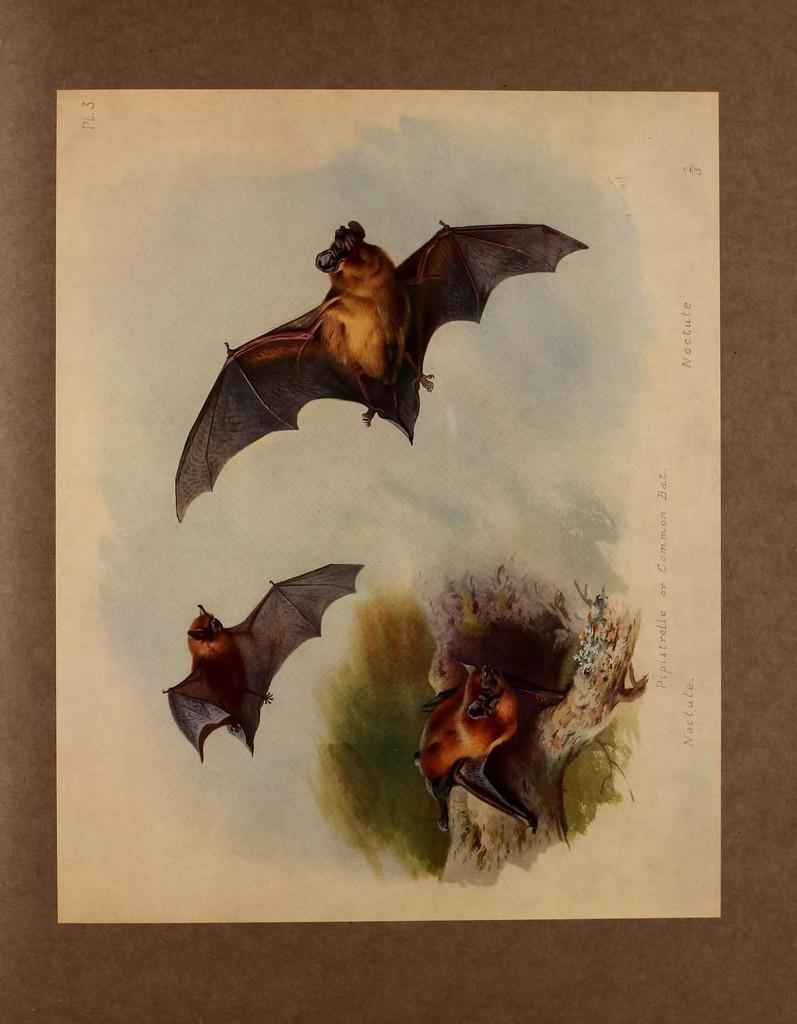What type of artwork is depicted in the image? The image is a painting. What animals are present in the painting? There are bats in the painting. What other object can be seen in the painting? There is a tree trunk in the painting. What color is the border of the painting? The painting has a brown border. How many trees are present on the journey depicted in the painting? There is no journey depicted in the painting, and only one tree trunk is visible. Can you tell me the color of the toad sitting on the tree trunk in the painting? There is no toad present in the painting; only bats and a tree trunk are visible. 